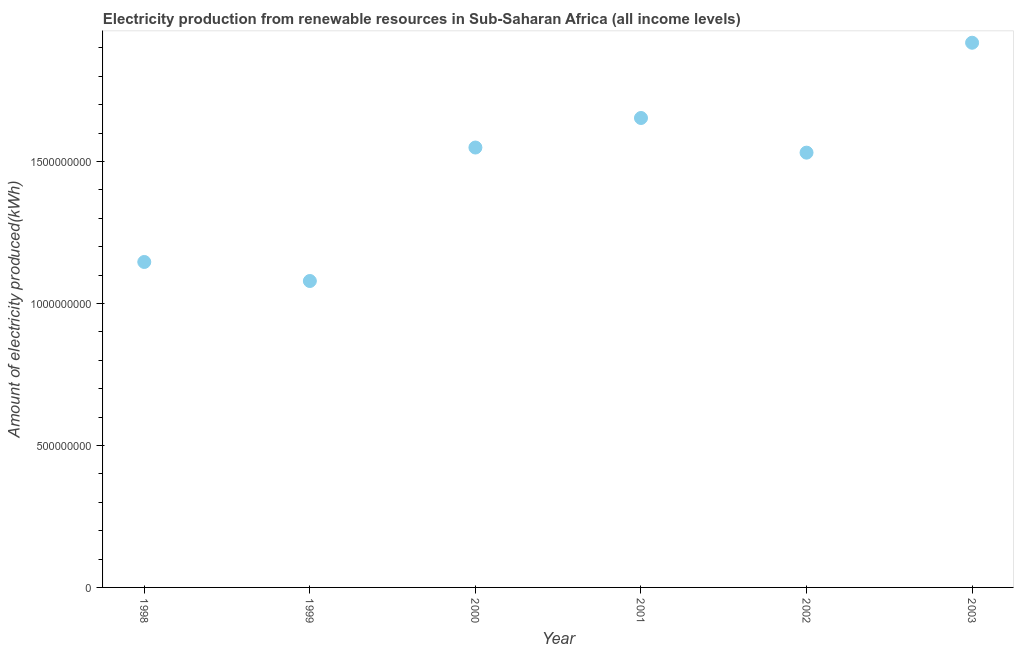What is the amount of electricity produced in 1999?
Keep it short and to the point. 1.08e+09. Across all years, what is the maximum amount of electricity produced?
Provide a succinct answer. 1.92e+09. Across all years, what is the minimum amount of electricity produced?
Offer a very short reply. 1.08e+09. What is the sum of the amount of electricity produced?
Your answer should be very brief. 8.88e+09. What is the difference between the amount of electricity produced in 1998 and 2003?
Your response must be concise. -7.72e+08. What is the average amount of electricity produced per year?
Your answer should be compact. 1.48e+09. What is the median amount of electricity produced?
Keep it short and to the point. 1.54e+09. In how many years, is the amount of electricity produced greater than 1400000000 kWh?
Provide a short and direct response. 4. What is the ratio of the amount of electricity produced in 1998 to that in 2002?
Offer a terse response. 0.75. Is the amount of electricity produced in 1998 less than that in 1999?
Your answer should be very brief. No. What is the difference between the highest and the second highest amount of electricity produced?
Your answer should be very brief. 2.65e+08. What is the difference between the highest and the lowest amount of electricity produced?
Keep it short and to the point. 8.39e+08. In how many years, is the amount of electricity produced greater than the average amount of electricity produced taken over all years?
Offer a terse response. 4. Does the amount of electricity produced monotonically increase over the years?
Your response must be concise. No. How many dotlines are there?
Offer a very short reply. 1. How many years are there in the graph?
Ensure brevity in your answer.  6. What is the difference between two consecutive major ticks on the Y-axis?
Ensure brevity in your answer.  5.00e+08. Are the values on the major ticks of Y-axis written in scientific E-notation?
Your answer should be compact. No. Does the graph contain any zero values?
Offer a terse response. No. Does the graph contain grids?
Give a very brief answer. No. What is the title of the graph?
Offer a terse response. Electricity production from renewable resources in Sub-Saharan Africa (all income levels). What is the label or title of the X-axis?
Give a very brief answer. Year. What is the label or title of the Y-axis?
Your response must be concise. Amount of electricity produced(kWh). What is the Amount of electricity produced(kWh) in 1998?
Your answer should be compact. 1.15e+09. What is the Amount of electricity produced(kWh) in 1999?
Your answer should be compact. 1.08e+09. What is the Amount of electricity produced(kWh) in 2000?
Provide a succinct answer. 1.55e+09. What is the Amount of electricity produced(kWh) in 2001?
Keep it short and to the point. 1.65e+09. What is the Amount of electricity produced(kWh) in 2002?
Your response must be concise. 1.53e+09. What is the Amount of electricity produced(kWh) in 2003?
Make the answer very short. 1.92e+09. What is the difference between the Amount of electricity produced(kWh) in 1998 and 1999?
Provide a succinct answer. 6.70e+07. What is the difference between the Amount of electricity produced(kWh) in 1998 and 2000?
Your answer should be very brief. -4.03e+08. What is the difference between the Amount of electricity produced(kWh) in 1998 and 2001?
Offer a very short reply. -5.07e+08. What is the difference between the Amount of electricity produced(kWh) in 1998 and 2002?
Your response must be concise. -3.85e+08. What is the difference between the Amount of electricity produced(kWh) in 1998 and 2003?
Provide a succinct answer. -7.72e+08. What is the difference between the Amount of electricity produced(kWh) in 1999 and 2000?
Provide a short and direct response. -4.70e+08. What is the difference between the Amount of electricity produced(kWh) in 1999 and 2001?
Offer a terse response. -5.74e+08. What is the difference between the Amount of electricity produced(kWh) in 1999 and 2002?
Keep it short and to the point. -4.52e+08. What is the difference between the Amount of electricity produced(kWh) in 1999 and 2003?
Ensure brevity in your answer.  -8.39e+08. What is the difference between the Amount of electricity produced(kWh) in 2000 and 2001?
Give a very brief answer. -1.04e+08. What is the difference between the Amount of electricity produced(kWh) in 2000 and 2002?
Ensure brevity in your answer.  1.80e+07. What is the difference between the Amount of electricity produced(kWh) in 2000 and 2003?
Offer a very short reply. -3.69e+08. What is the difference between the Amount of electricity produced(kWh) in 2001 and 2002?
Your response must be concise. 1.22e+08. What is the difference between the Amount of electricity produced(kWh) in 2001 and 2003?
Provide a succinct answer. -2.65e+08. What is the difference between the Amount of electricity produced(kWh) in 2002 and 2003?
Give a very brief answer. -3.87e+08. What is the ratio of the Amount of electricity produced(kWh) in 1998 to that in 1999?
Offer a terse response. 1.06. What is the ratio of the Amount of electricity produced(kWh) in 1998 to that in 2000?
Keep it short and to the point. 0.74. What is the ratio of the Amount of electricity produced(kWh) in 1998 to that in 2001?
Ensure brevity in your answer.  0.69. What is the ratio of the Amount of electricity produced(kWh) in 1998 to that in 2002?
Provide a succinct answer. 0.75. What is the ratio of the Amount of electricity produced(kWh) in 1998 to that in 2003?
Keep it short and to the point. 0.6. What is the ratio of the Amount of electricity produced(kWh) in 1999 to that in 2000?
Provide a succinct answer. 0.7. What is the ratio of the Amount of electricity produced(kWh) in 1999 to that in 2001?
Offer a very short reply. 0.65. What is the ratio of the Amount of electricity produced(kWh) in 1999 to that in 2002?
Provide a succinct answer. 0.7. What is the ratio of the Amount of electricity produced(kWh) in 1999 to that in 2003?
Offer a very short reply. 0.56. What is the ratio of the Amount of electricity produced(kWh) in 2000 to that in 2001?
Your answer should be very brief. 0.94. What is the ratio of the Amount of electricity produced(kWh) in 2000 to that in 2002?
Offer a terse response. 1.01. What is the ratio of the Amount of electricity produced(kWh) in 2000 to that in 2003?
Ensure brevity in your answer.  0.81. What is the ratio of the Amount of electricity produced(kWh) in 2001 to that in 2002?
Make the answer very short. 1.08. What is the ratio of the Amount of electricity produced(kWh) in 2001 to that in 2003?
Provide a short and direct response. 0.86. What is the ratio of the Amount of electricity produced(kWh) in 2002 to that in 2003?
Provide a short and direct response. 0.8. 